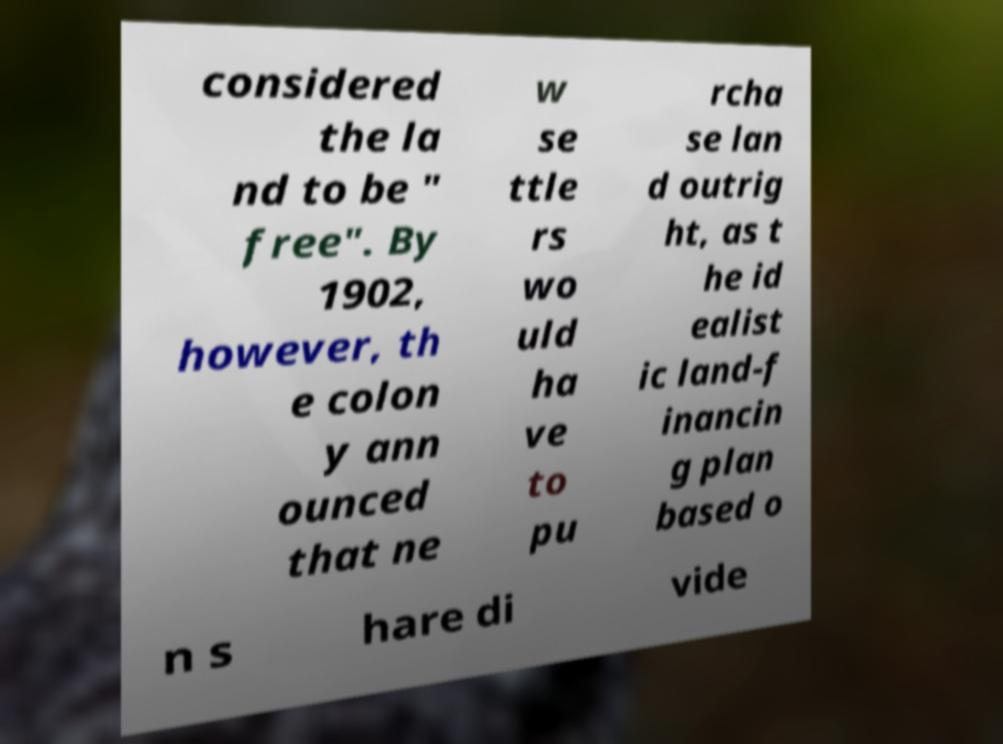Could you extract and type out the text from this image? considered the la nd to be " free". By 1902, however, th e colon y ann ounced that ne w se ttle rs wo uld ha ve to pu rcha se lan d outrig ht, as t he id ealist ic land-f inancin g plan based o n s hare di vide 